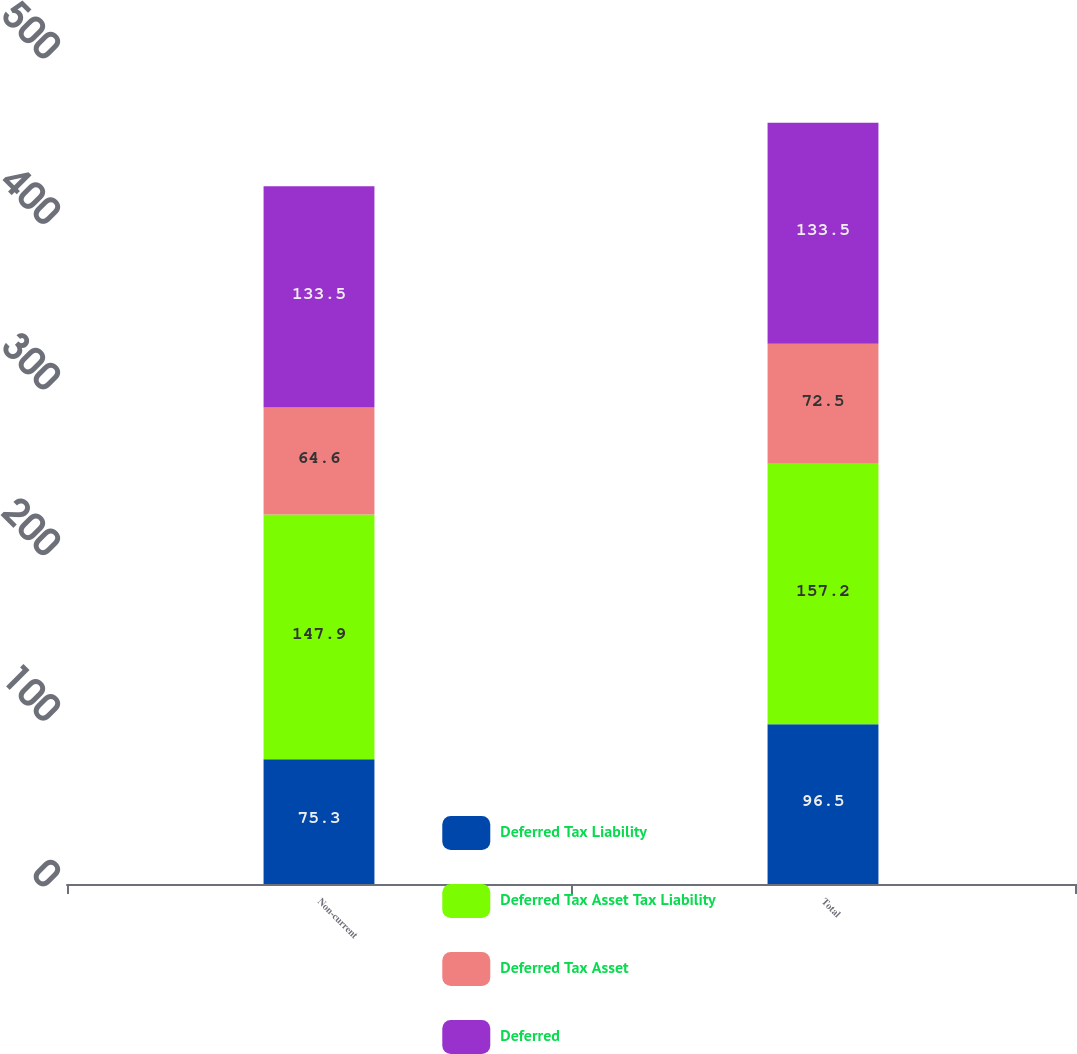Convert chart. <chart><loc_0><loc_0><loc_500><loc_500><stacked_bar_chart><ecel><fcel>Non-current<fcel>Total<nl><fcel>Deferred Tax Liability<fcel>75.3<fcel>96.5<nl><fcel>Deferred Tax Asset Tax Liability<fcel>147.9<fcel>157.2<nl><fcel>Deferred Tax Asset<fcel>64.6<fcel>72.5<nl><fcel>Deferred<fcel>133.5<fcel>133.5<nl></chart> 